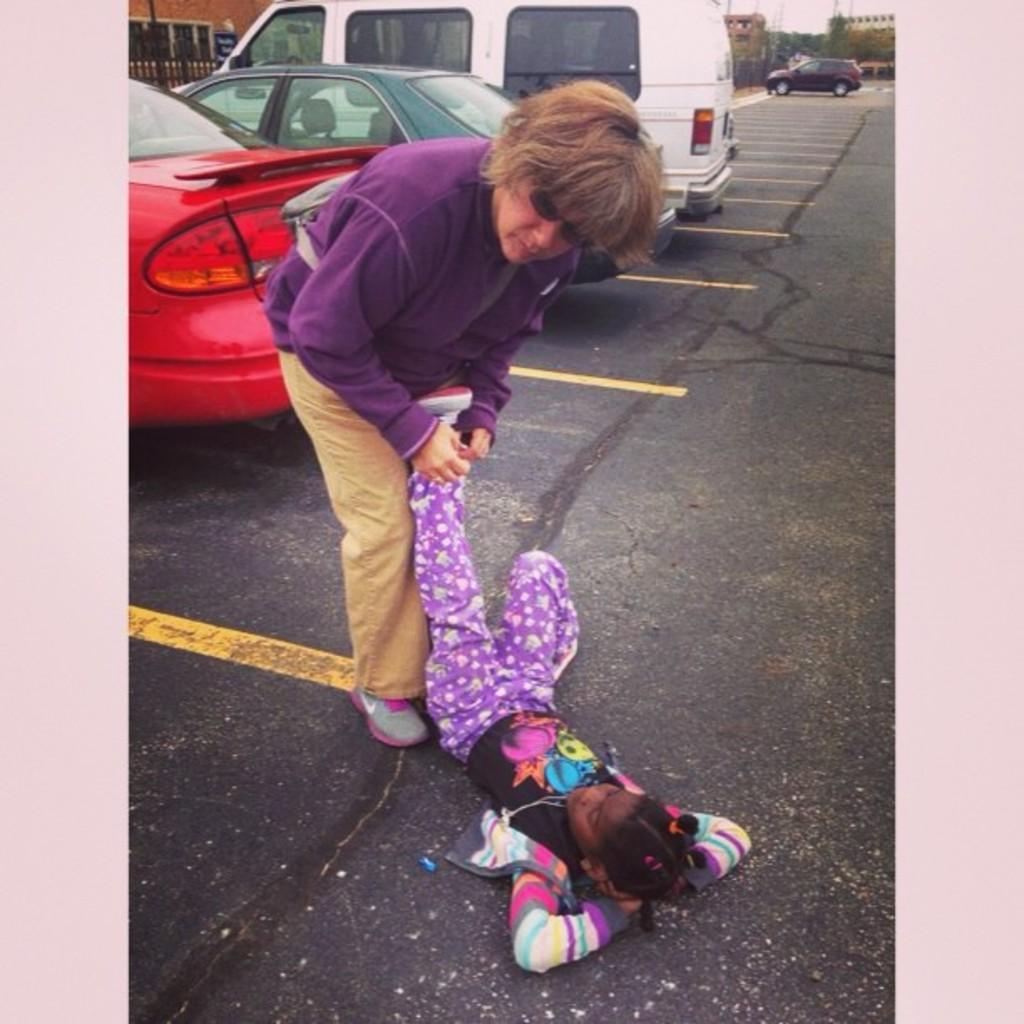Describe this image in one or two sentences. There is a girl laying on the road and he is holding a girl leg. We can see vehicles on the road, fence and board. In the background we can see buildings, trees and sky. 